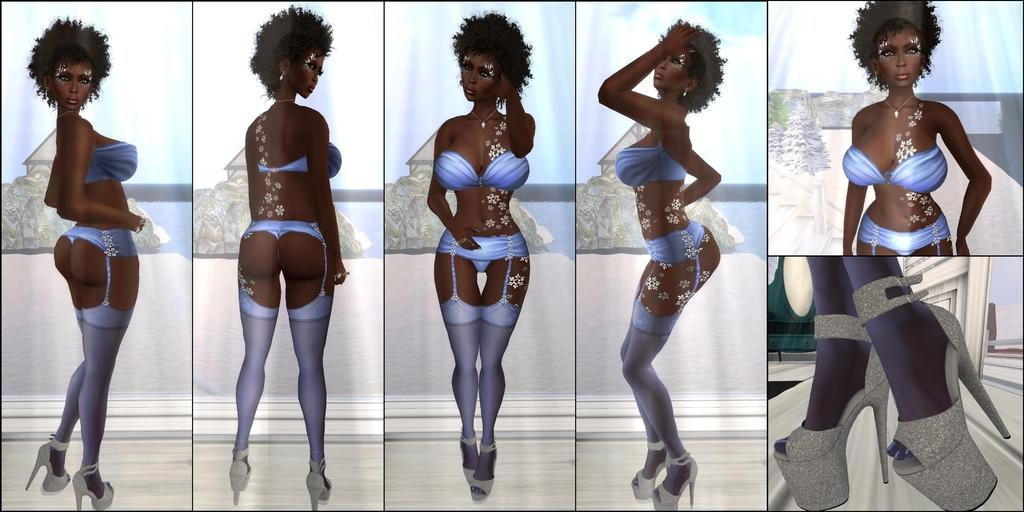What type of artwork is shown in the image? The image is a collage. What subjects are depicted in the collage? There are depictions of a woman in the image. What type of jar is being balanced by the woman in the image? There is no jar or any indication of balancing in the image; it only depicts a woman. 